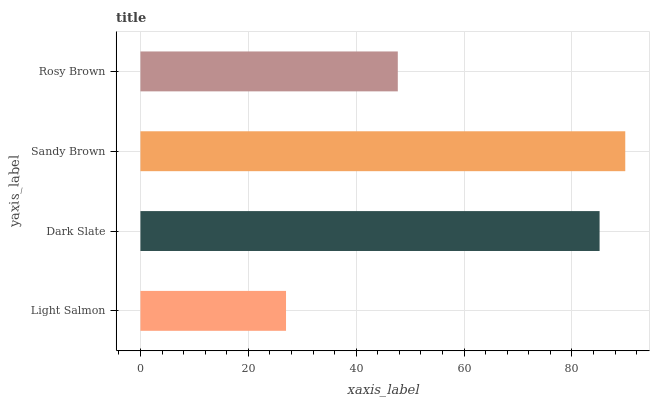Is Light Salmon the minimum?
Answer yes or no. Yes. Is Sandy Brown the maximum?
Answer yes or no. Yes. Is Dark Slate the minimum?
Answer yes or no. No. Is Dark Slate the maximum?
Answer yes or no. No. Is Dark Slate greater than Light Salmon?
Answer yes or no. Yes. Is Light Salmon less than Dark Slate?
Answer yes or no. Yes. Is Light Salmon greater than Dark Slate?
Answer yes or no. No. Is Dark Slate less than Light Salmon?
Answer yes or no. No. Is Dark Slate the high median?
Answer yes or no. Yes. Is Rosy Brown the low median?
Answer yes or no. Yes. Is Rosy Brown the high median?
Answer yes or no. No. Is Dark Slate the low median?
Answer yes or no. No. 